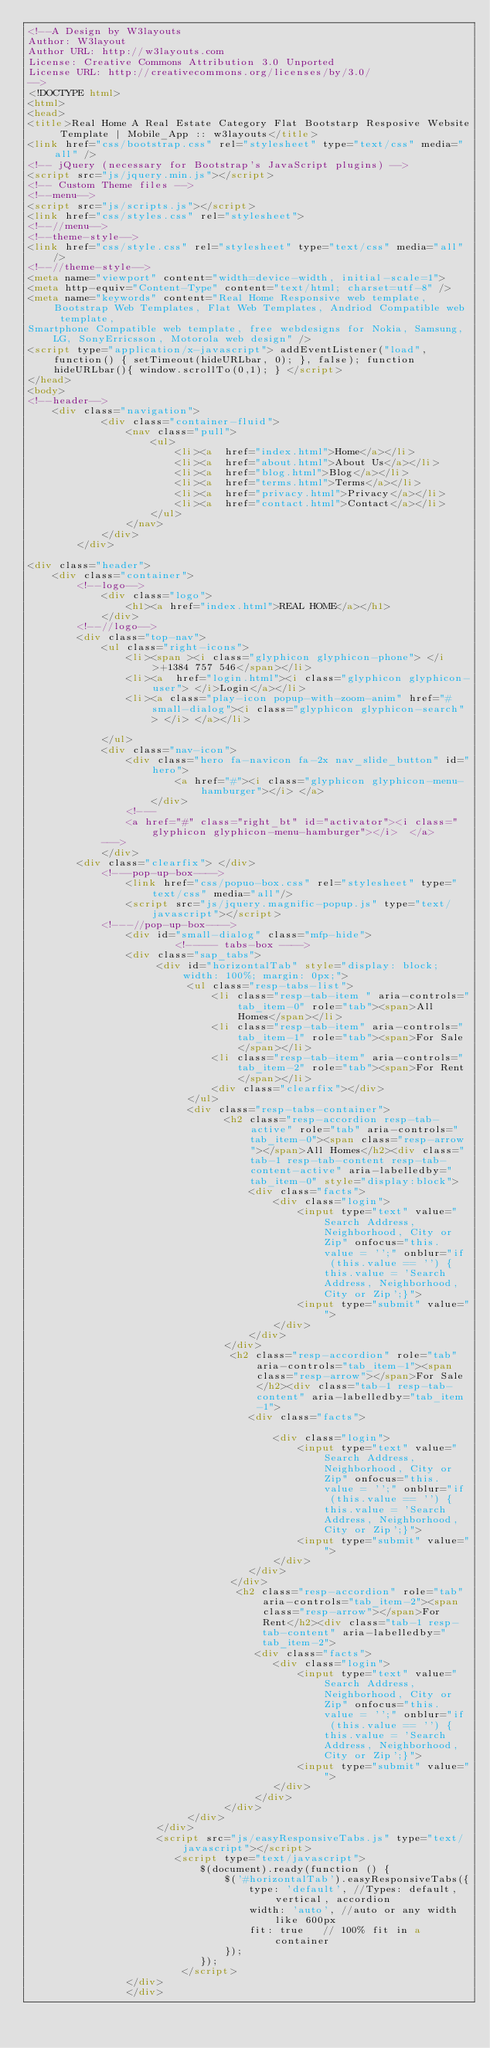<code> <loc_0><loc_0><loc_500><loc_500><_HTML_><!--A Design by W3layouts 
Author: W3layout
Author URL: http://w3layouts.com
License: Creative Commons Attribution 3.0 Unported
License URL: http://creativecommons.org/licenses/by/3.0/
-->
<!DOCTYPE html>
<html>
<head>
<title>Real Home A Real Estate Category Flat Bootstarp Resposive Website Template | Mobile_App :: w3layouts</title>
<link href="css/bootstrap.css" rel="stylesheet" type="text/css" media="all" />
<!-- jQuery (necessary for Bootstrap's JavaScript plugins) -->
<script src="js/jquery.min.js"></script>
<!-- Custom Theme files -->
<!--menu-->
<script src="js/scripts.js"></script>
<link href="css/styles.css" rel="stylesheet">
<!--//menu-->
<!--theme-style-->
<link href="css/style.css" rel="stylesheet" type="text/css" media="all" />	
<!--//theme-style-->
<meta name="viewport" content="width=device-width, initial-scale=1">
<meta http-equiv="Content-Type" content="text/html; charset=utf-8" />
<meta name="keywords" content="Real Home Responsive web template, Bootstrap Web Templates, Flat Web Templates, Andriod Compatible web template, 
Smartphone Compatible web template, free webdesigns for Nokia, Samsung, LG, SonyErricsson, Motorola web design" />
<script type="application/x-javascript"> addEventListener("load", function() { setTimeout(hideURLbar, 0); }, false); function hideURLbar(){ window.scrollTo(0,1); } </script>
</head>
<body>
<!--header-->
	<div class="navigation">
			<div class="container-fluid">
				<nav class="pull">
					<ul>
						<li><a  href="index.html">Home</a></li>
						<li><a  href="about.html">About Us</a></li>
						<li><a  href="blog.html">Blog</a></li>
						<li><a  href="terms.html">Terms</a></li>
						<li><a  href="privacy.html">Privacy</a></li>
						<li><a  href="contact.html">Contact</a></li>
					</ul>
				</nav>			
			</div>
		</div>

<div class="header">
	<div class="container">
		<!--logo-->
			<div class="logo">
				<h1><a href="index.html">REAL HOME</a></h1>
			</div>
		<!--//logo-->
		<div class="top-nav">
			<ul class="right-icons">
				<li><span ><i class="glyphicon glyphicon-phone"> </i>+1384 757 546</span></li>
				<li><a  href="login.html"><i class="glyphicon glyphicon-user"> </i>Login</a></li>
				<li><a class="play-icon popup-with-zoom-anim" href="#small-dialog"><i class="glyphicon glyphicon-search"> </i> </a></li>
				
			</ul>
			<div class="nav-icon">
				<div class="hero fa-navicon fa-2x nav_slide_button" id="hero">
						<a href="#"><i class="glyphicon glyphicon-menu-hamburger"></i> </a>
					</div>	
				<!---
				<a href="#" class="right_bt" id="activator"><i class="glyphicon glyphicon-menu-hamburger"></i>  </a>
			--->
			</div>
		<div class="clearfix"> </div>
			<!---pop-up-box---->   
				<link href="css/popuo-box.css" rel="stylesheet" type="text/css" media="all"/>
				<script src="js/jquery.magnific-popup.js" type="text/javascript"></script>
			<!---//pop-up-box---->
				<div id="small-dialog" class="mfp-hide">
					    <!----- tabs-box ---->
				<div class="sap_tabs">	
				     <div id="horizontalTab" style="display: block; width: 100%; margin: 0px;">
						  <ul class="resp-tabs-list">
						  	  <li class="resp-tab-item " aria-controls="tab_item-0" role="tab"><span>All Homes</span></li>
							  <li class="resp-tab-item" aria-controls="tab_item-1" role="tab"><span>For Sale</span></li>
							  <li class="resp-tab-item" aria-controls="tab_item-2" role="tab"><span>For Rent</span></li>
							  <div class="clearfix"></div>
						  </ul>				  	 
						  <div class="resp-tabs-container">
						  		<h2 class="resp-accordion resp-tab-active" role="tab" aria-controls="tab_item-0"><span class="resp-arrow"></span>All Homes</h2><div class="tab-1 resp-tab-content resp-tab-content-active" aria-labelledby="tab_item-0" style="display:block">
								 	<div class="facts">
									  	<div class="login">
											<input type="text" value="Search Address, Neighborhood, City or Zip" onfocus="this.value = '';" onblur="if (this.value == '') {this.value = 'Search Address, Neighborhood, City or Zip';}">		
									 		<input type="submit" value="">
									 	</div>        
							        </div>
						  		</div>
							     <h2 class="resp-accordion" role="tab" aria-controls="tab_item-1"><span class="resp-arrow"></span>For Sale</h2><div class="tab-1 resp-tab-content" aria-labelledby="tab_item-1">
									<div class="facts">									
										<div class="login">
											<input type="text" value="Search Address, Neighborhood, City or Zip" onfocus="this.value = '';" onblur="if (this.value == '') {this.value = 'Search Address, Neighborhood, City or Zip';}">		
									 		<input type="submit" value="">
									 	</div> 
							        </div>	
								 </div>									
							      <h2 class="resp-accordion" role="tab" aria-controls="tab_item-2"><span class="resp-arrow"></span>For Rent</h2><div class="tab-1 resp-tab-content" aria-labelledby="tab_item-2">
									 <div class="facts">
										<div class="login">
											<input type="text" value="Search Address, Neighborhood, City or Zip" onfocus="this.value = '';" onblur="if (this.value == '') {this.value = 'Search Address, Neighborhood, City or Zip';}">		
									 		<input type="submit" value="">
									 	</div> 
							         </div>	
							    </div>
					      </div>
					 </div>
					 <script src="js/easyResponsiveTabs.js" type="text/javascript"></script>
				    	<script type="text/javascript">
						    $(document).ready(function () {
						        $('#horizontalTab').easyResponsiveTabs({
						            type: 'default', //Types: default, vertical, accordion           
						            width: 'auto', //auto or any width like 600px
						            fit: true   // 100% fit in a container
						        });
						    });
			  			 </script>	
				</div>
				</div></code> 